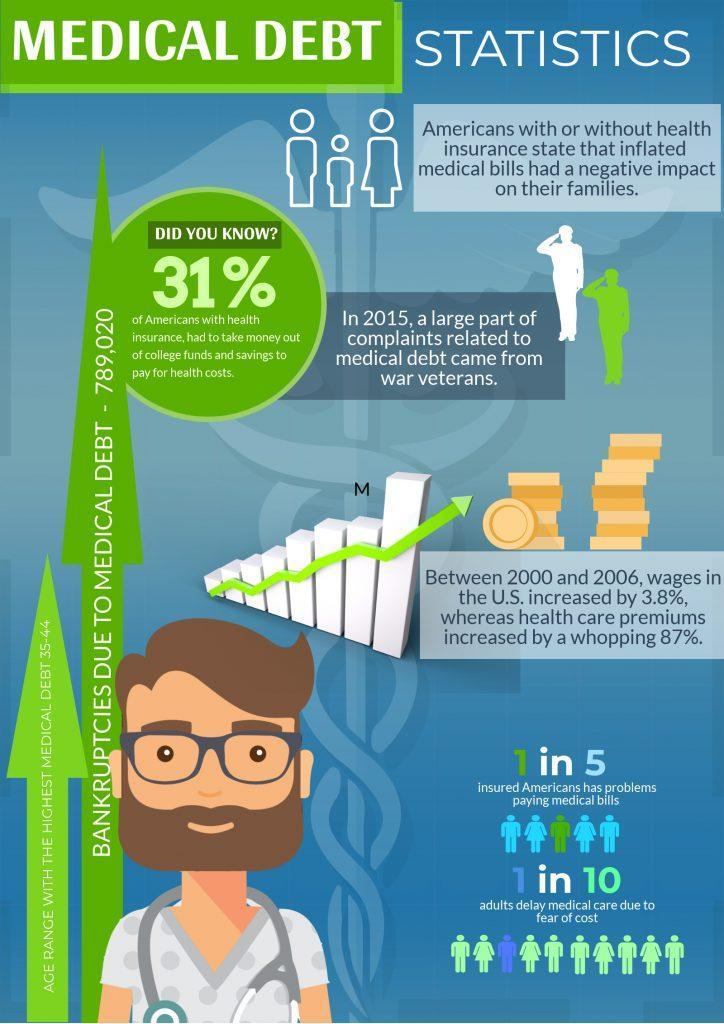what are the other sources of fund other than health insurance to pay for health cost
Answer the question with a short phrase. college funds and savings what percentage delay medical care due to cost 10 what percentage of americans have problems paying medical bill 20 what was the wage increase in 6 years 3.8% what letter is written in black above the green arrow M 